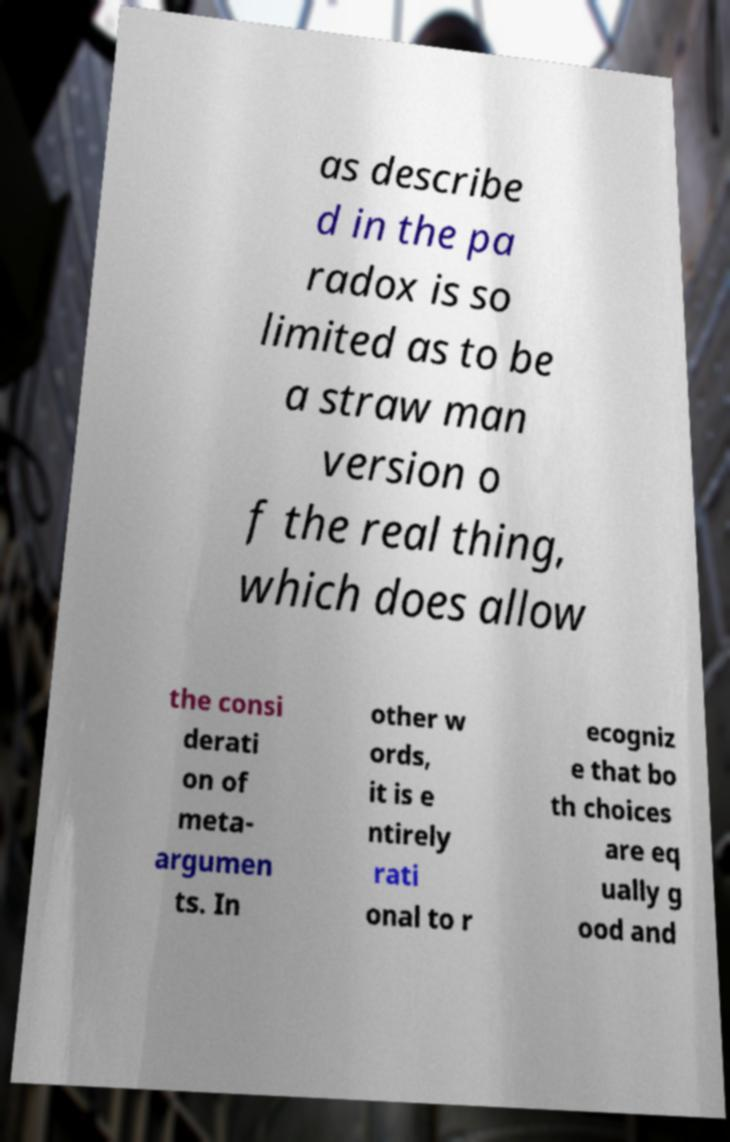What messages or text are displayed in this image? I need them in a readable, typed format. as describe d in the pa radox is so limited as to be a straw man version o f the real thing, which does allow the consi derati on of meta- argumen ts. In other w ords, it is e ntirely rati onal to r ecogniz e that bo th choices are eq ually g ood and 